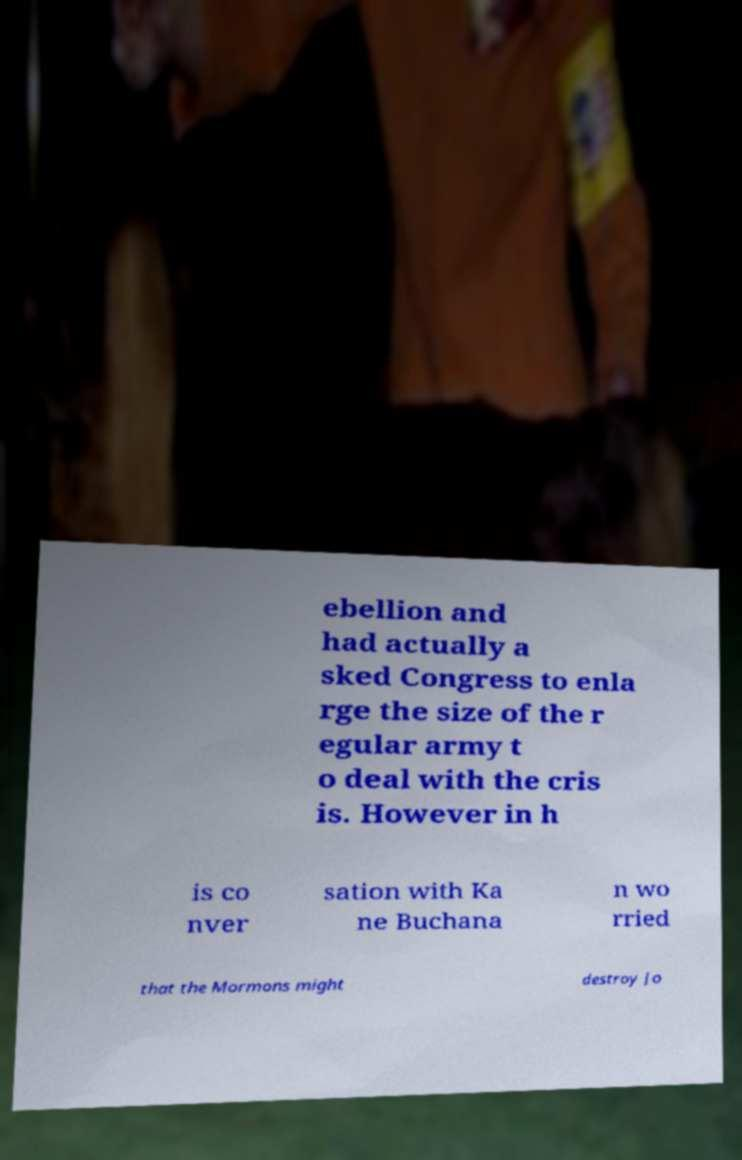Please identify and transcribe the text found in this image. ebellion and had actually a sked Congress to enla rge the size of the r egular army t o deal with the cris is. However in h is co nver sation with Ka ne Buchana n wo rried that the Mormons might destroy Jo 